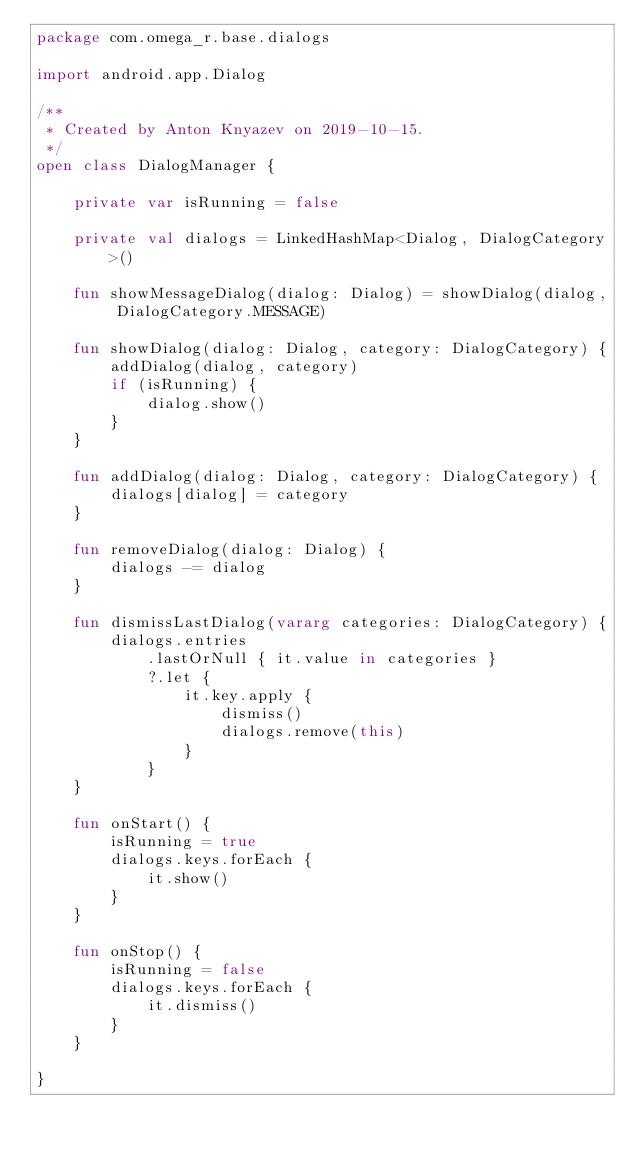Convert code to text. <code><loc_0><loc_0><loc_500><loc_500><_Kotlin_>package com.omega_r.base.dialogs

import android.app.Dialog

/**
 * Created by Anton Knyazev on 2019-10-15.
 */
open class DialogManager {

    private var isRunning = false

    private val dialogs = LinkedHashMap<Dialog, DialogCategory>()

    fun showMessageDialog(dialog: Dialog) = showDialog(dialog, DialogCategory.MESSAGE)

    fun showDialog(dialog: Dialog, category: DialogCategory) {
        addDialog(dialog, category)
        if (isRunning) {
            dialog.show()
        }
    }

    fun addDialog(dialog: Dialog, category: DialogCategory) {
        dialogs[dialog] = category
    }

    fun removeDialog(dialog: Dialog) {
        dialogs -= dialog
    }

    fun dismissLastDialog(vararg categories: DialogCategory) {
        dialogs.entries
            .lastOrNull { it.value in categories }
            ?.let {
                it.key.apply {
                    dismiss()
                    dialogs.remove(this)
                }
            }
    }

    fun onStart() {
        isRunning = true
        dialogs.keys.forEach {
            it.show()
        }
    }

    fun onStop() {
        isRunning = false
        dialogs.keys.forEach {
            it.dismiss()
        }
    }

}</code> 